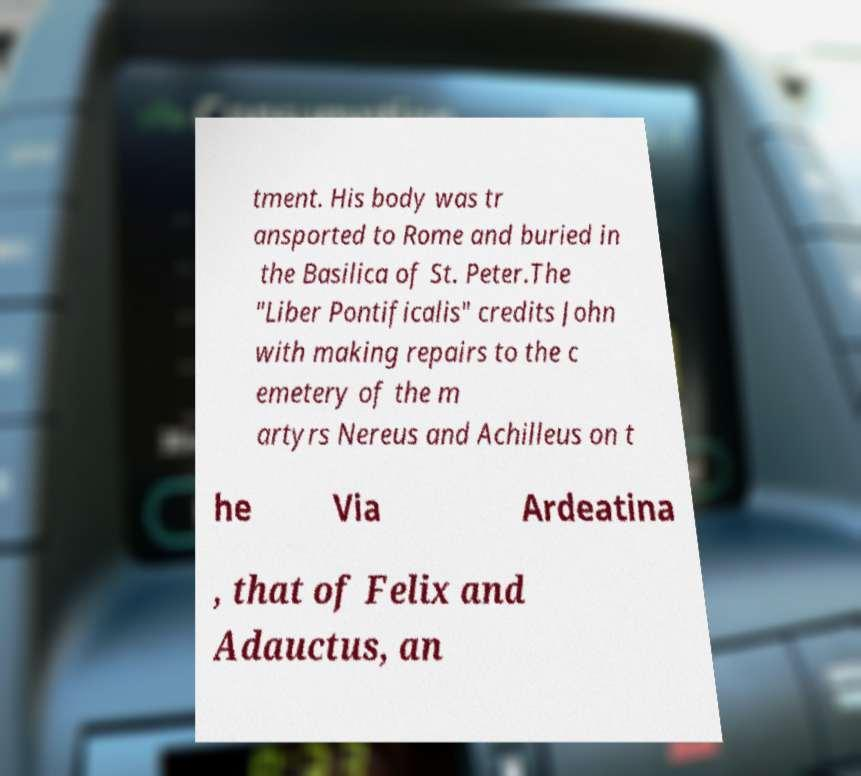What messages or text are displayed in this image? I need them in a readable, typed format. tment. His body was tr ansported to Rome and buried in the Basilica of St. Peter.The "Liber Pontificalis" credits John with making repairs to the c emetery of the m artyrs Nereus and Achilleus on t he Via Ardeatina , that of Felix and Adauctus, an 